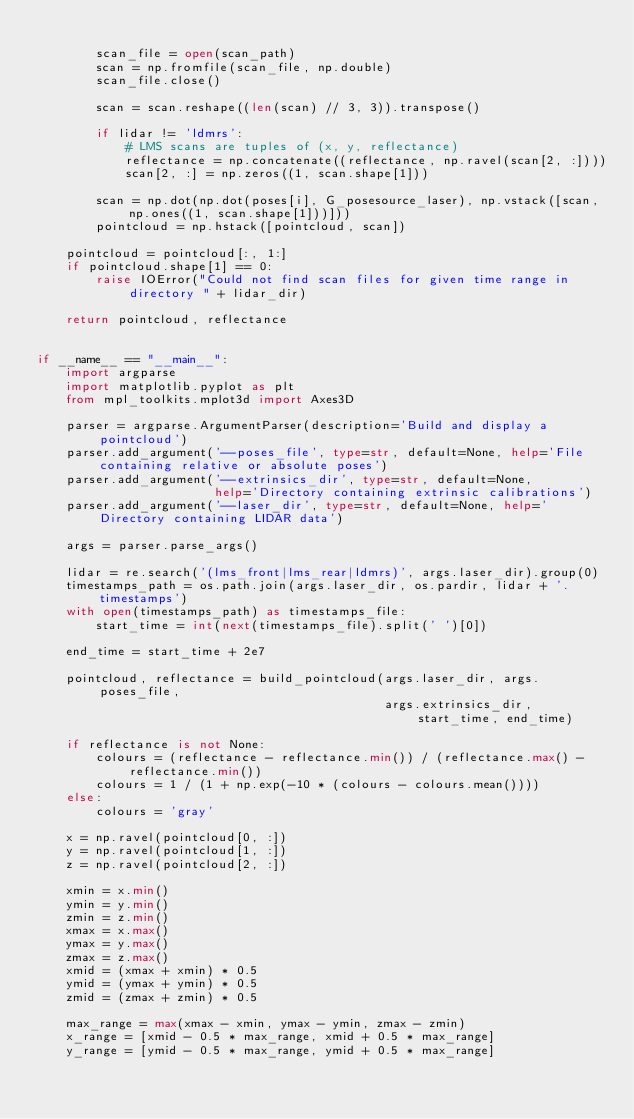Convert code to text. <code><loc_0><loc_0><loc_500><loc_500><_Python_>
        scan_file = open(scan_path)
        scan = np.fromfile(scan_file, np.double)
        scan_file.close()

        scan = scan.reshape((len(scan) // 3, 3)).transpose()

        if lidar != 'ldmrs':
            # LMS scans are tuples of (x, y, reflectance)
            reflectance = np.concatenate((reflectance, np.ravel(scan[2, :])))
            scan[2, :] = np.zeros((1, scan.shape[1]))

        scan = np.dot(np.dot(poses[i], G_posesource_laser), np.vstack([scan, np.ones((1, scan.shape[1]))]))
        pointcloud = np.hstack([pointcloud, scan])

    pointcloud = pointcloud[:, 1:]
    if pointcloud.shape[1] == 0:
        raise IOError("Could not find scan files for given time range in directory " + lidar_dir)

    return pointcloud, reflectance


if __name__ == "__main__":
    import argparse
    import matplotlib.pyplot as plt
    from mpl_toolkits.mplot3d import Axes3D

    parser = argparse.ArgumentParser(description='Build and display a pointcloud')
    parser.add_argument('--poses_file', type=str, default=None, help='File containing relative or absolute poses')
    parser.add_argument('--extrinsics_dir', type=str, default=None,
                        help='Directory containing extrinsic calibrations')
    parser.add_argument('--laser_dir', type=str, default=None, help='Directory containing LIDAR data')

    args = parser.parse_args()

    lidar = re.search('(lms_front|lms_rear|ldmrs)', args.laser_dir).group(0)
    timestamps_path = os.path.join(args.laser_dir, os.pardir, lidar + '.timestamps')
    with open(timestamps_path) as timestamps_file:
        start_time = int(next(timestamps_file).split(' ')[0])

    end_time = start_time + 2e7

    pointcloud, reflectance = build_pointcloud(args.laser_dir, args.poses_file,
                                               args.extrinsics_dir, start_time, end_time)

    if reflectance is not None:
        colours = (reflectance - reflectance.min()) / (reflectance.max() - reflectance.min())
        colours = 1 / (1 + np.exp(-10 * (colours - colours.mean())))
    else:
        colours = 'gray'

    x = np.ravel(pointcloud[0, :])
    y = np.ravel(pointcloud[1, :])
    z = np.ravel(pointcloud[2, :])

    xmin = x.min()
    ymin = y.min()
    zmin = z.min()
    xmax = x.max()
    ymax = y.max()
    zmax = z.max()
    xmid = (xmax + xmin) * 0.5
    ymid = (ymax + ymin) * 0.5
    zmid = (zmax + zmin) * 0.5

    max_range = max(xmax - xmin, ymax - ymin, zmax - zmin)
    x_range = [xmid - 0.5 * max_range, xmid + 0.5 * max_range]
    y_range = [ymid - 0.5 * max_range, ymid + 0.5 * max_range]</code> 